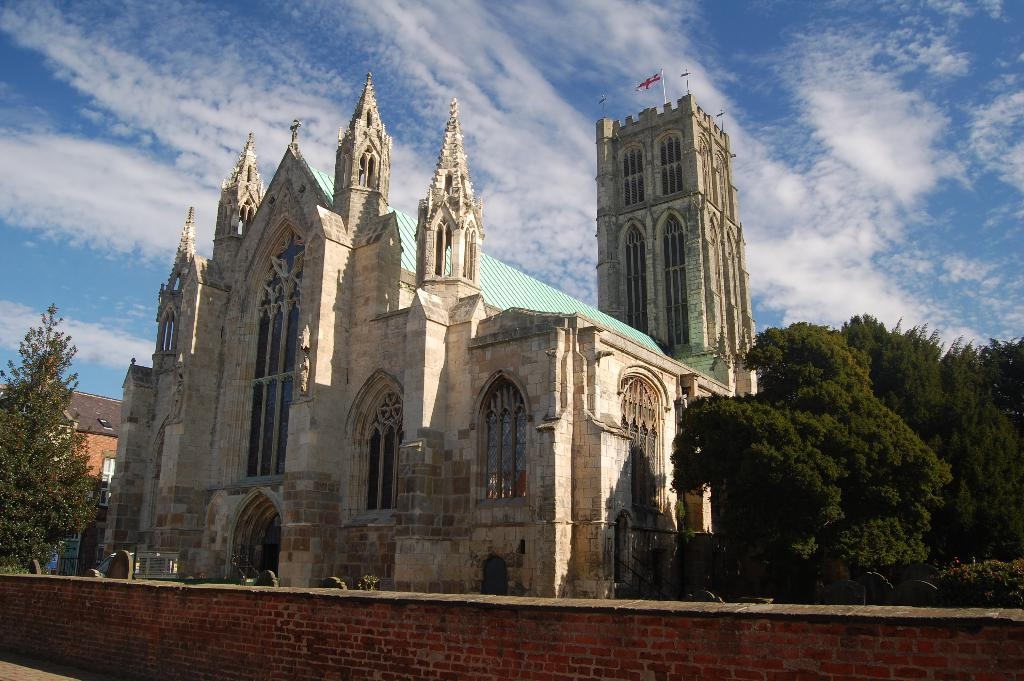What type of structure is depicted in the image? There is an architecture in the image. What can be seen surrounding the architecture? There are trees around the architecture. Is there any barrier or obstacle in front of the architecture? Yes, there is a wall in front of the architecture. What type of thrill can be experienced while standing near the architecture in the image? There is no indication of any thrill or activity in the image; it simply depicts a structure with trees and a wall. 